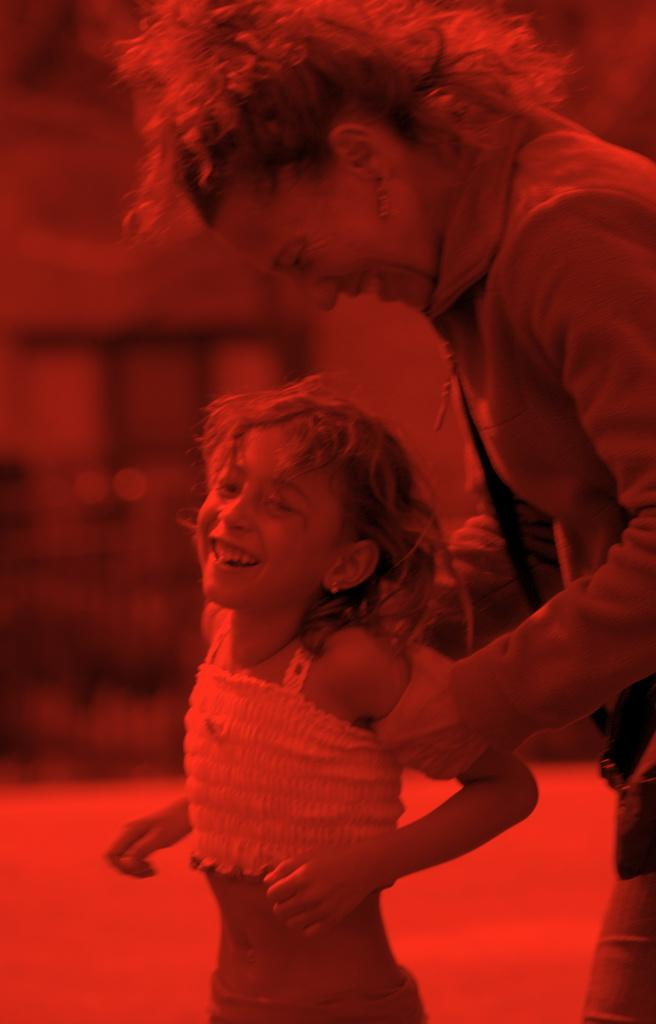Who is present in the image? There is a woman and a kid in the image. What can be observed about the image's editing? The image has been edited. What is the appearance of the background in the image? The background of the image is blurred. What type of bells can be heard ringing in the image? There are no bells present in the image, and therefore no sound can be heard. 